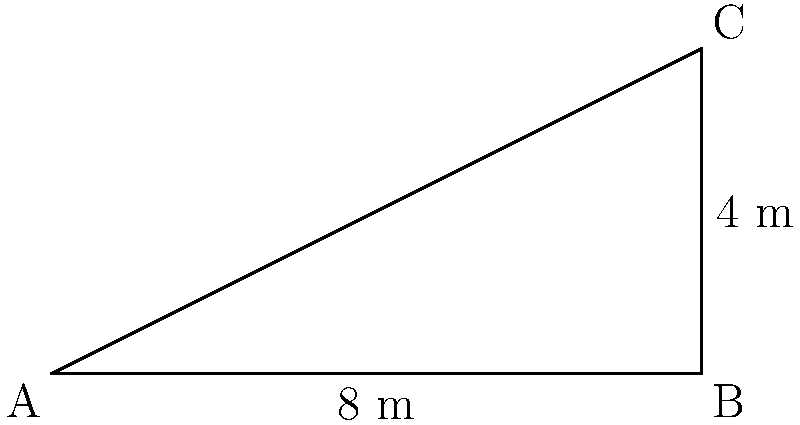At an archaeological site in Susa, ancient Elamite stairs were discovered. The horizontal distance (run) of each step is 8 meters, and the vertical rise is 4 meters. What is the angle of inclination of these stairs with respect to the horizontal plane? To find the angle of inclination, we can use the trigonometric relationship in a right triangle formed by the stairs:

1) The run of the stairs forms the base of the right triangle (adjacent to the angle we're looking for).
2) The rise of the stairs forms the height of the right triangle (opposite to the angle).
3) The hypotenuse is the actual length of the stairs.

We can use the tangent function to find the angle:

$$\tan(\theta) = \frac{\text{opposite}}{\text{adjacent}} = \frac{\text{rise}}{\text{run}}$$

Plugging in our values:

$$\tan(\theta) = \frac{4 \text{ m}}{8 \text{ m}} = \frac{1}{2} = 0.5$$

To find the angle, we need to take the inverse tangent (arctan or $\tan^{-1}$):

$$\theta = \tan^{-1}(0.5)$$

Using a calculator or trigonometric tables:

$$\theta \approx 26.57°$$

Therefore, the angle of inclination of the Elamite stairs is approximately 26.57 degrees.
Answer: $26.57°$ 